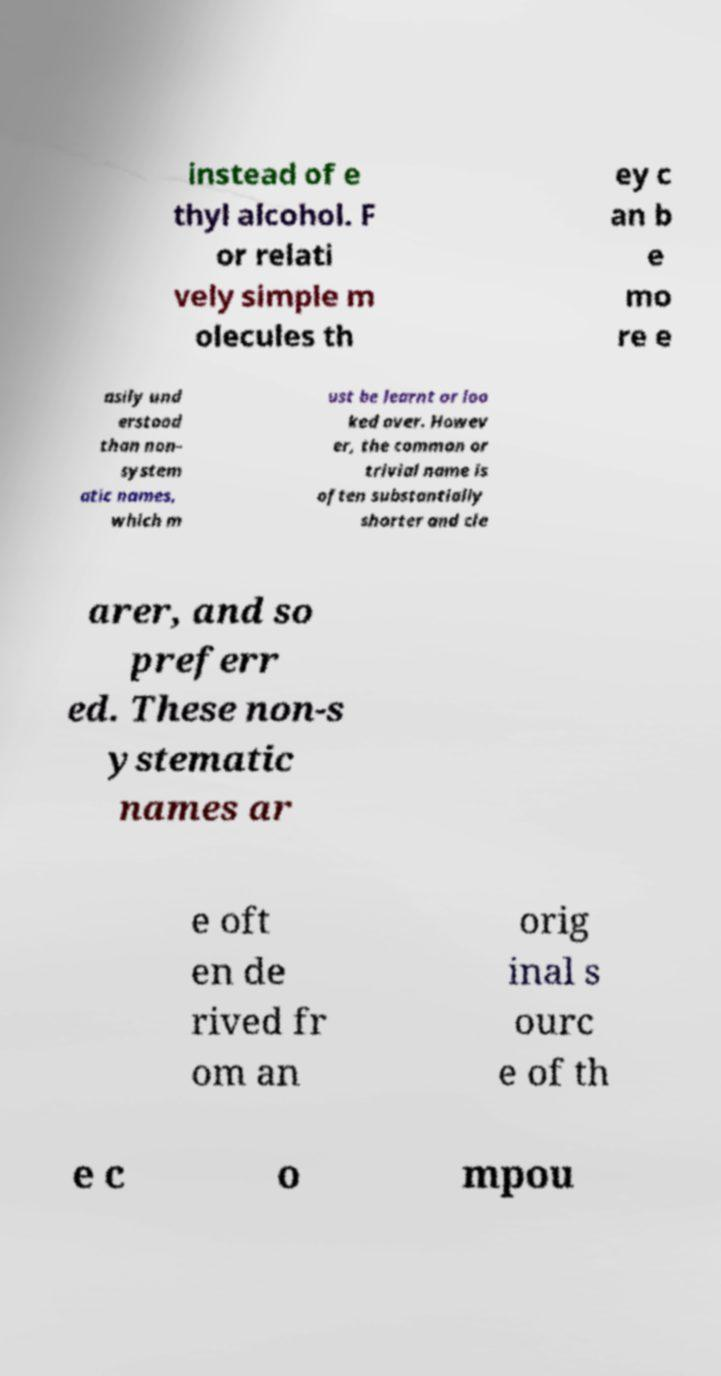Please read and relay the text visible in this image. What does it say? instead of e thyl alcohol. F or relati vely simple m olecules th ey c an b e mo re e asily und erstood than non- system atic names, which m ust be learnt or loo ked over. Howev er, the common or trivial name is often substantially shorter and cle arer, and so preferr ed. These non-s ystematic names ar e oft en de rived fr om an orig inal s ourc e of th e c o mpou 